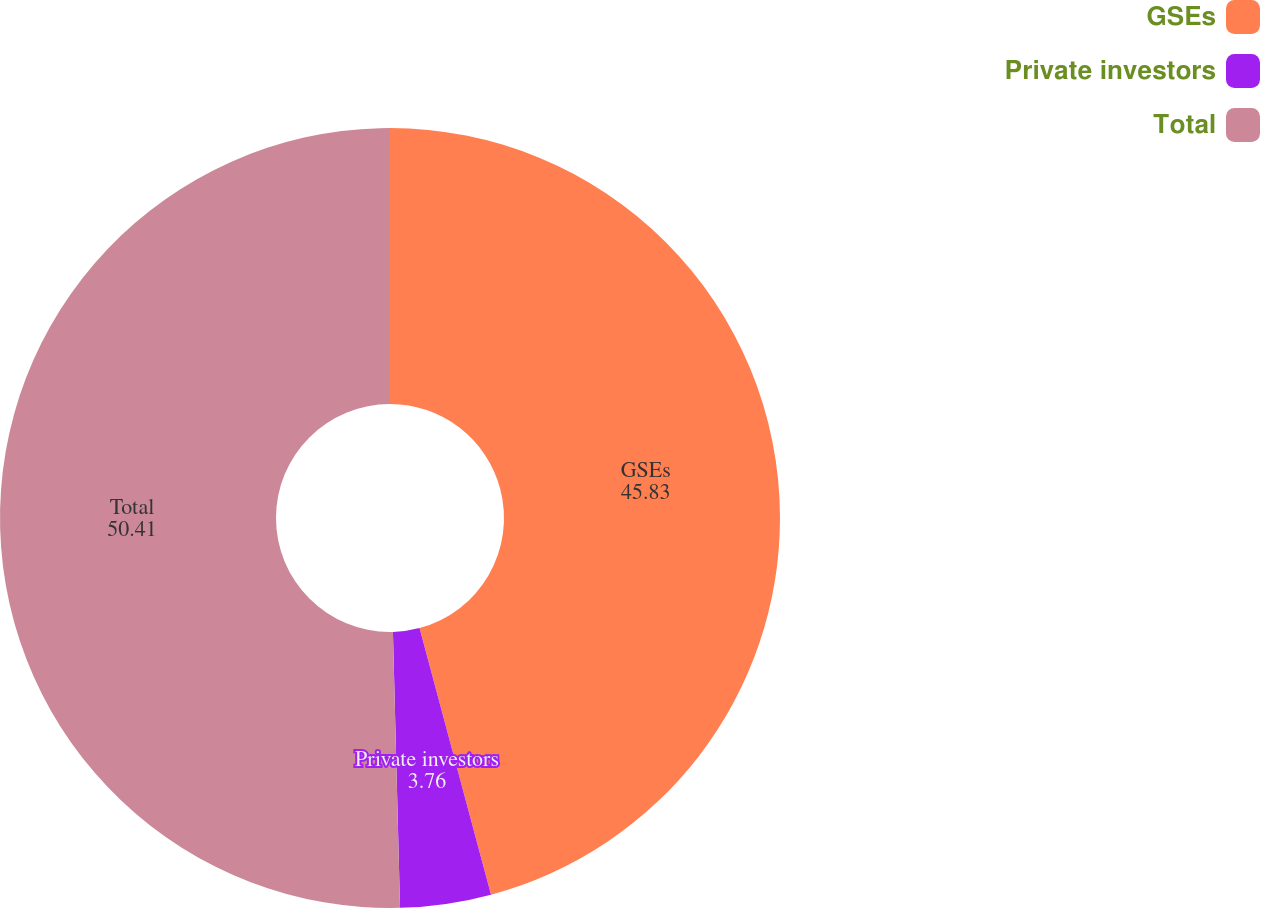Convert chart to OTSL. <chart><loc_0><loc_0><loc_500><loc_500><pie_chart><fcel>GSEs<fcel>Private investors<fcel>Total<nl><fcel>45.83%<fcel>3.76%<fcel>50.41%<nl></chart> 